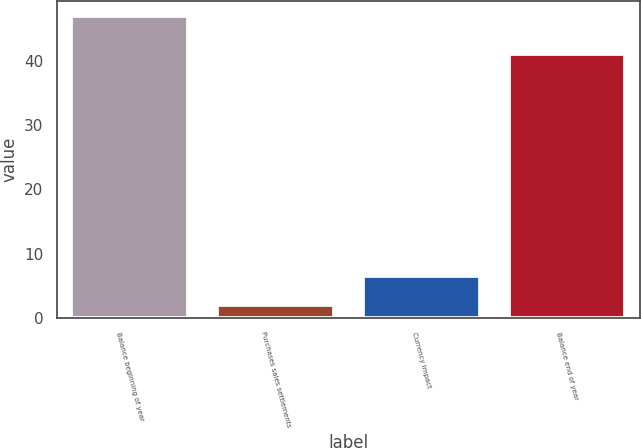<chart> <loc_0><loc_0><loc_500><loc_500><bar_chart><fcel>Balance beginning of year<fcel>Purchases sales settlements<fcel>Currency impact<fcel>Balance end of year<nl><fcel>47<fcel>2<fcel>6.5<fcel>41<nl></chart> 